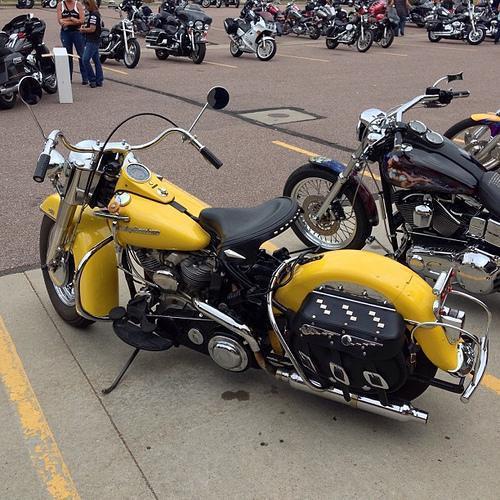How many yellow bikes?
Give a very brief answer. 2. How many white post?
Give a very brief answer. 1. How many people?
Give a very brief answer. 3. 